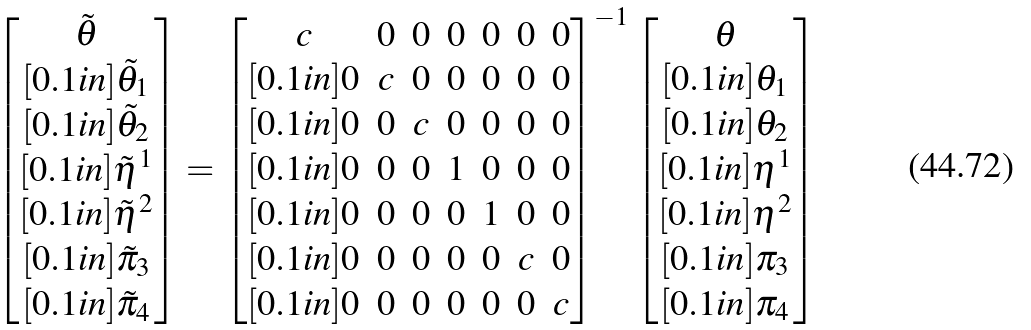Convert formula to latex. <formula><loc_0><loc_0><loc_500><loc_500>\begin{bmatrix} \tilde { \theta } \\ [ 0 . 1 i n ] \tilde { \theta } _ { 1 } \\ [ 0 . 1 i n ] \tilde { \theta } _ { 2 } \\ [ 0 . 1 i n ] \tilde { \eta } ^ { 1 } \\ [ 0 . 1 i n ] \tilde { \eta } ^ { 2 } \\ [ 0 . 1 i n ] \tilde { \pi } _ { 3 } \\ [ 0 . 1 i n ] \tilde { \pi } _ { 4 } \end{bmatrix} = \begin{bmatrix} c & 0 & 0 & 0 & 0 & 0 & 0 \\ [ 0 . 1 i n ] 0 & c & 0 & 0 & 0 & 0 & 0 \\ [ 0 . 1 i n ] 0 & 0 & c & 0 & 0 & 0 & 0 \\ [ 0 . 1 i n ] 0 & 0 & 0 & 1 & 0 & 0 & 0 \\ [ 0 . 1 i n ] 0 & 0 & 0 & 0 & 1 & 0 & 0 \\ [ 0 . 1 i n ] 0 & 0 & 0 & 0 & 0 & c & 0 \\ [ 0 . 1 i n ] 0 & 0 & 0 & 0 & 0 & 0 & c \end{bmatrix} ^ { - 1 } \begin{bmatrix} \theta \\ [ 0 . 1 i n ] \theta _ { 1 } \\ [ 0 . 1 i n ] \theta _ { 2 } \\ [ 0 . 1 i n ] \eta ^ { 1 } \\ [ 0 . 1 i n ] \eta ^ { 2 } \\ [ 0 . 1 i n ] \pi _ { 3 } \\ [ 0 . 1 i n ] \pi _ { 4 } \end{bmatrix}</formula> 